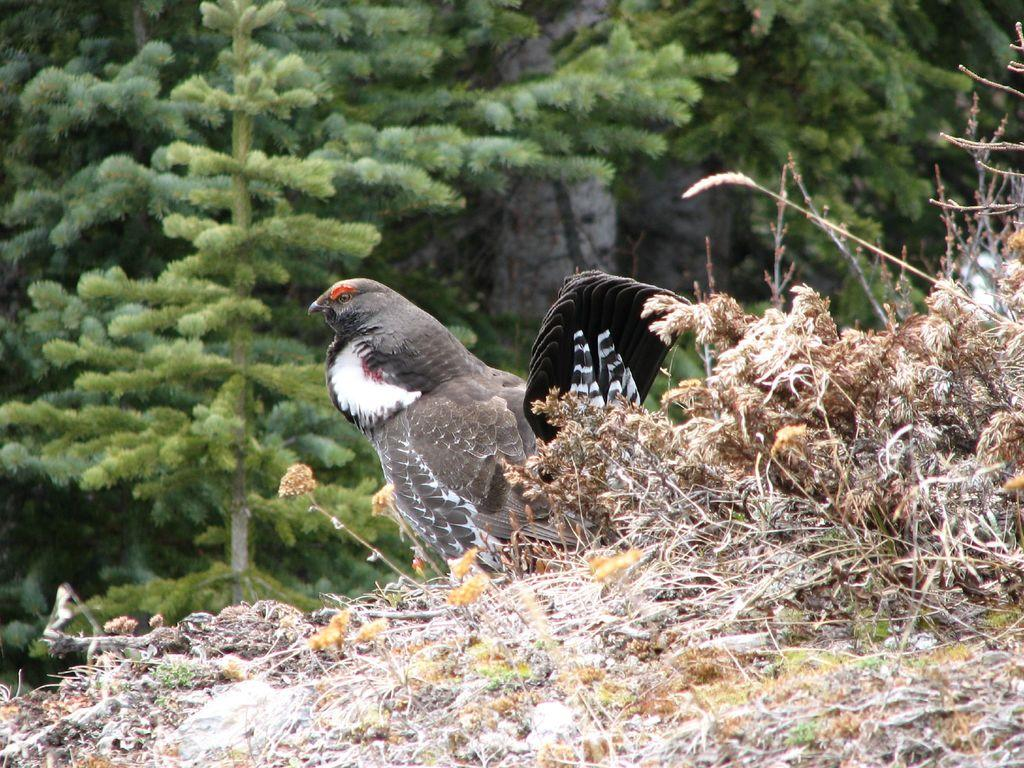What is the main subject in the foreground of the image? There is a bird in the foreground of the image. Where is the bird located? The bird is on the grass. What can be seen in the background of the image? There are trees and a building in the background of the image. Can you determine the time of day the image was taken? The image was likely taken during the day, as there is no indication of darkness or artificial lighting. What is the value of the bird's design in the image? There is no indication of the bird's design or any value associated with it in the image. 